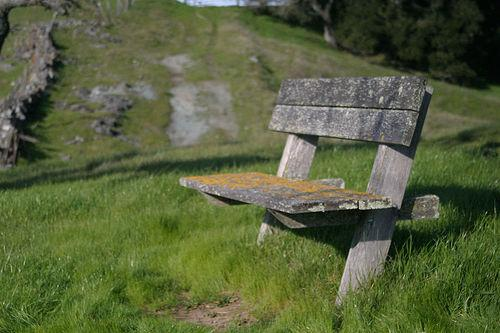Question: what color is the bench?
Choices:
A. Red.
B. White.
C. Blue.
D. Grey.
Answer with the letter. Answer: D Question: what is the bench made from?
Choices:
A. Steel.
B. Aluminum.
C. Wood.
D. Concrete.
Answer with the letter. Answer: C Question: what is in the grass in the background?
Choices:
A. Easter eggs.
B. Rocks.
C. Flowers.
D. Goats.
Answer with the letter. Answer: B 